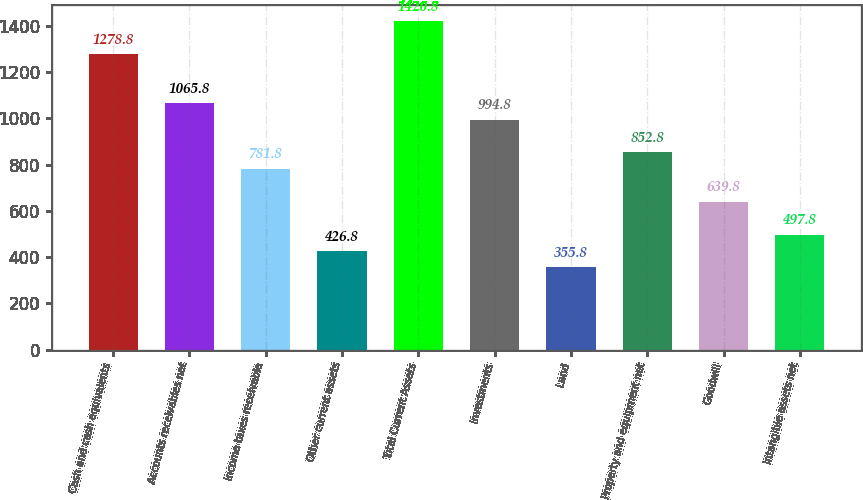Convert chart to OTSL. <chart><loc_0><loc_0><loc_500><loc_500><bar_chart><fcel>Cash and cash equivalents<fcel>Accounts receivables net<fcel>Income taxes receivable<fcel>Other current assets<fcel>Total Current Assets<fcel>Investments<fcel>Land<fcel>Property and equipment net<fcel>Goodwill<fcel>Intangible assets net<nl><fcel>1278.8<fcel>1065.8<fcel>781.8<fcel>426.8<fcel>1420.8<fcel>994.8<fcel>355.8<fcel>852.8<fcel>639.8<fcel>497.8<nl></chart> 